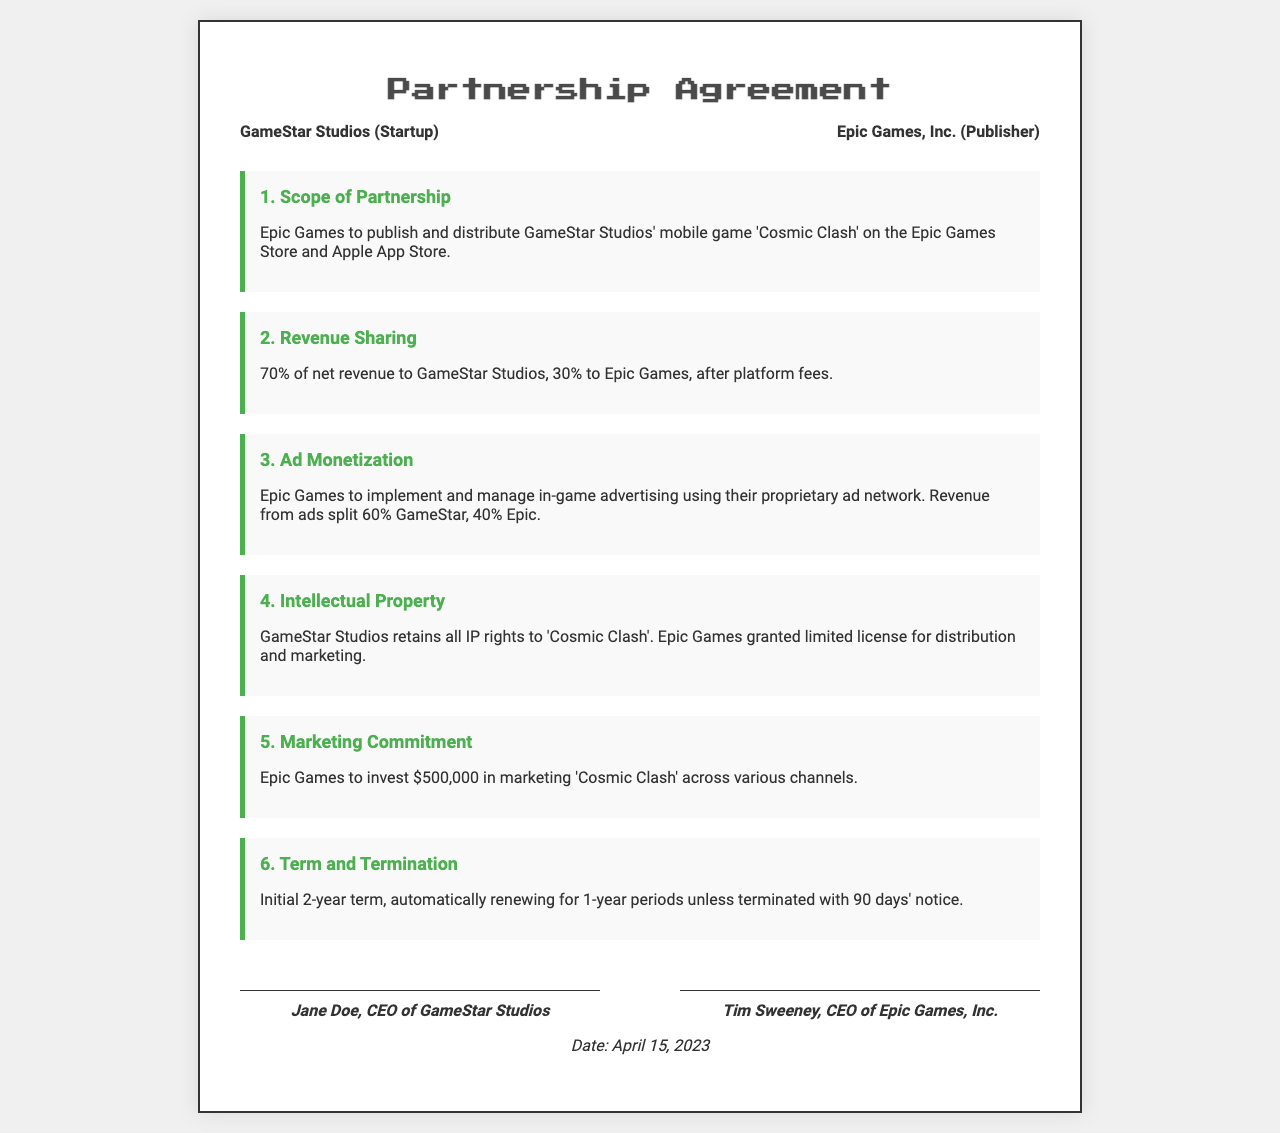what is the name of the mobile game? The document states that the mobile game is 'Cosmic Clash'.
Answer: 'Cosmic Clash' who are the parties involved in the partnership? The document lists GameStar Studios and Epic Games, Inc. as the parties involved.
Answer: GameStar Studios, Epic Games, Inc what percentage of net revenue goes to GameStar Studios? The revenue sharing section indicates that GameStar Studios receives 70% of net revenue.
Answer: 70% how much will Epic Games invest in marketing? The marketing commitment section specifies that Epic Games will invest $500,000 in marketing.
Answer: $500,000 what is the initial term of the agreement? The document states that the initial term of the agreement is 2 years.
Answer: 2 years who is the CEO of GameStar Studios? The signatories section identifies Jane Doe as the CEO of GameStar Studios.
Answer: Jane Doe how is the ad revenue split between the partners? In the ad monetization section, it indicates the revenue split is 60% for GameStar and 40% for Epic.
Answer: 60% GameStar, 40% Epic what rights does GameStar Studios retain? The intellectual property section mentions that GameStar Studios retains all IP rights to 'Cosmic Clash'.
Answer: All IP rights 